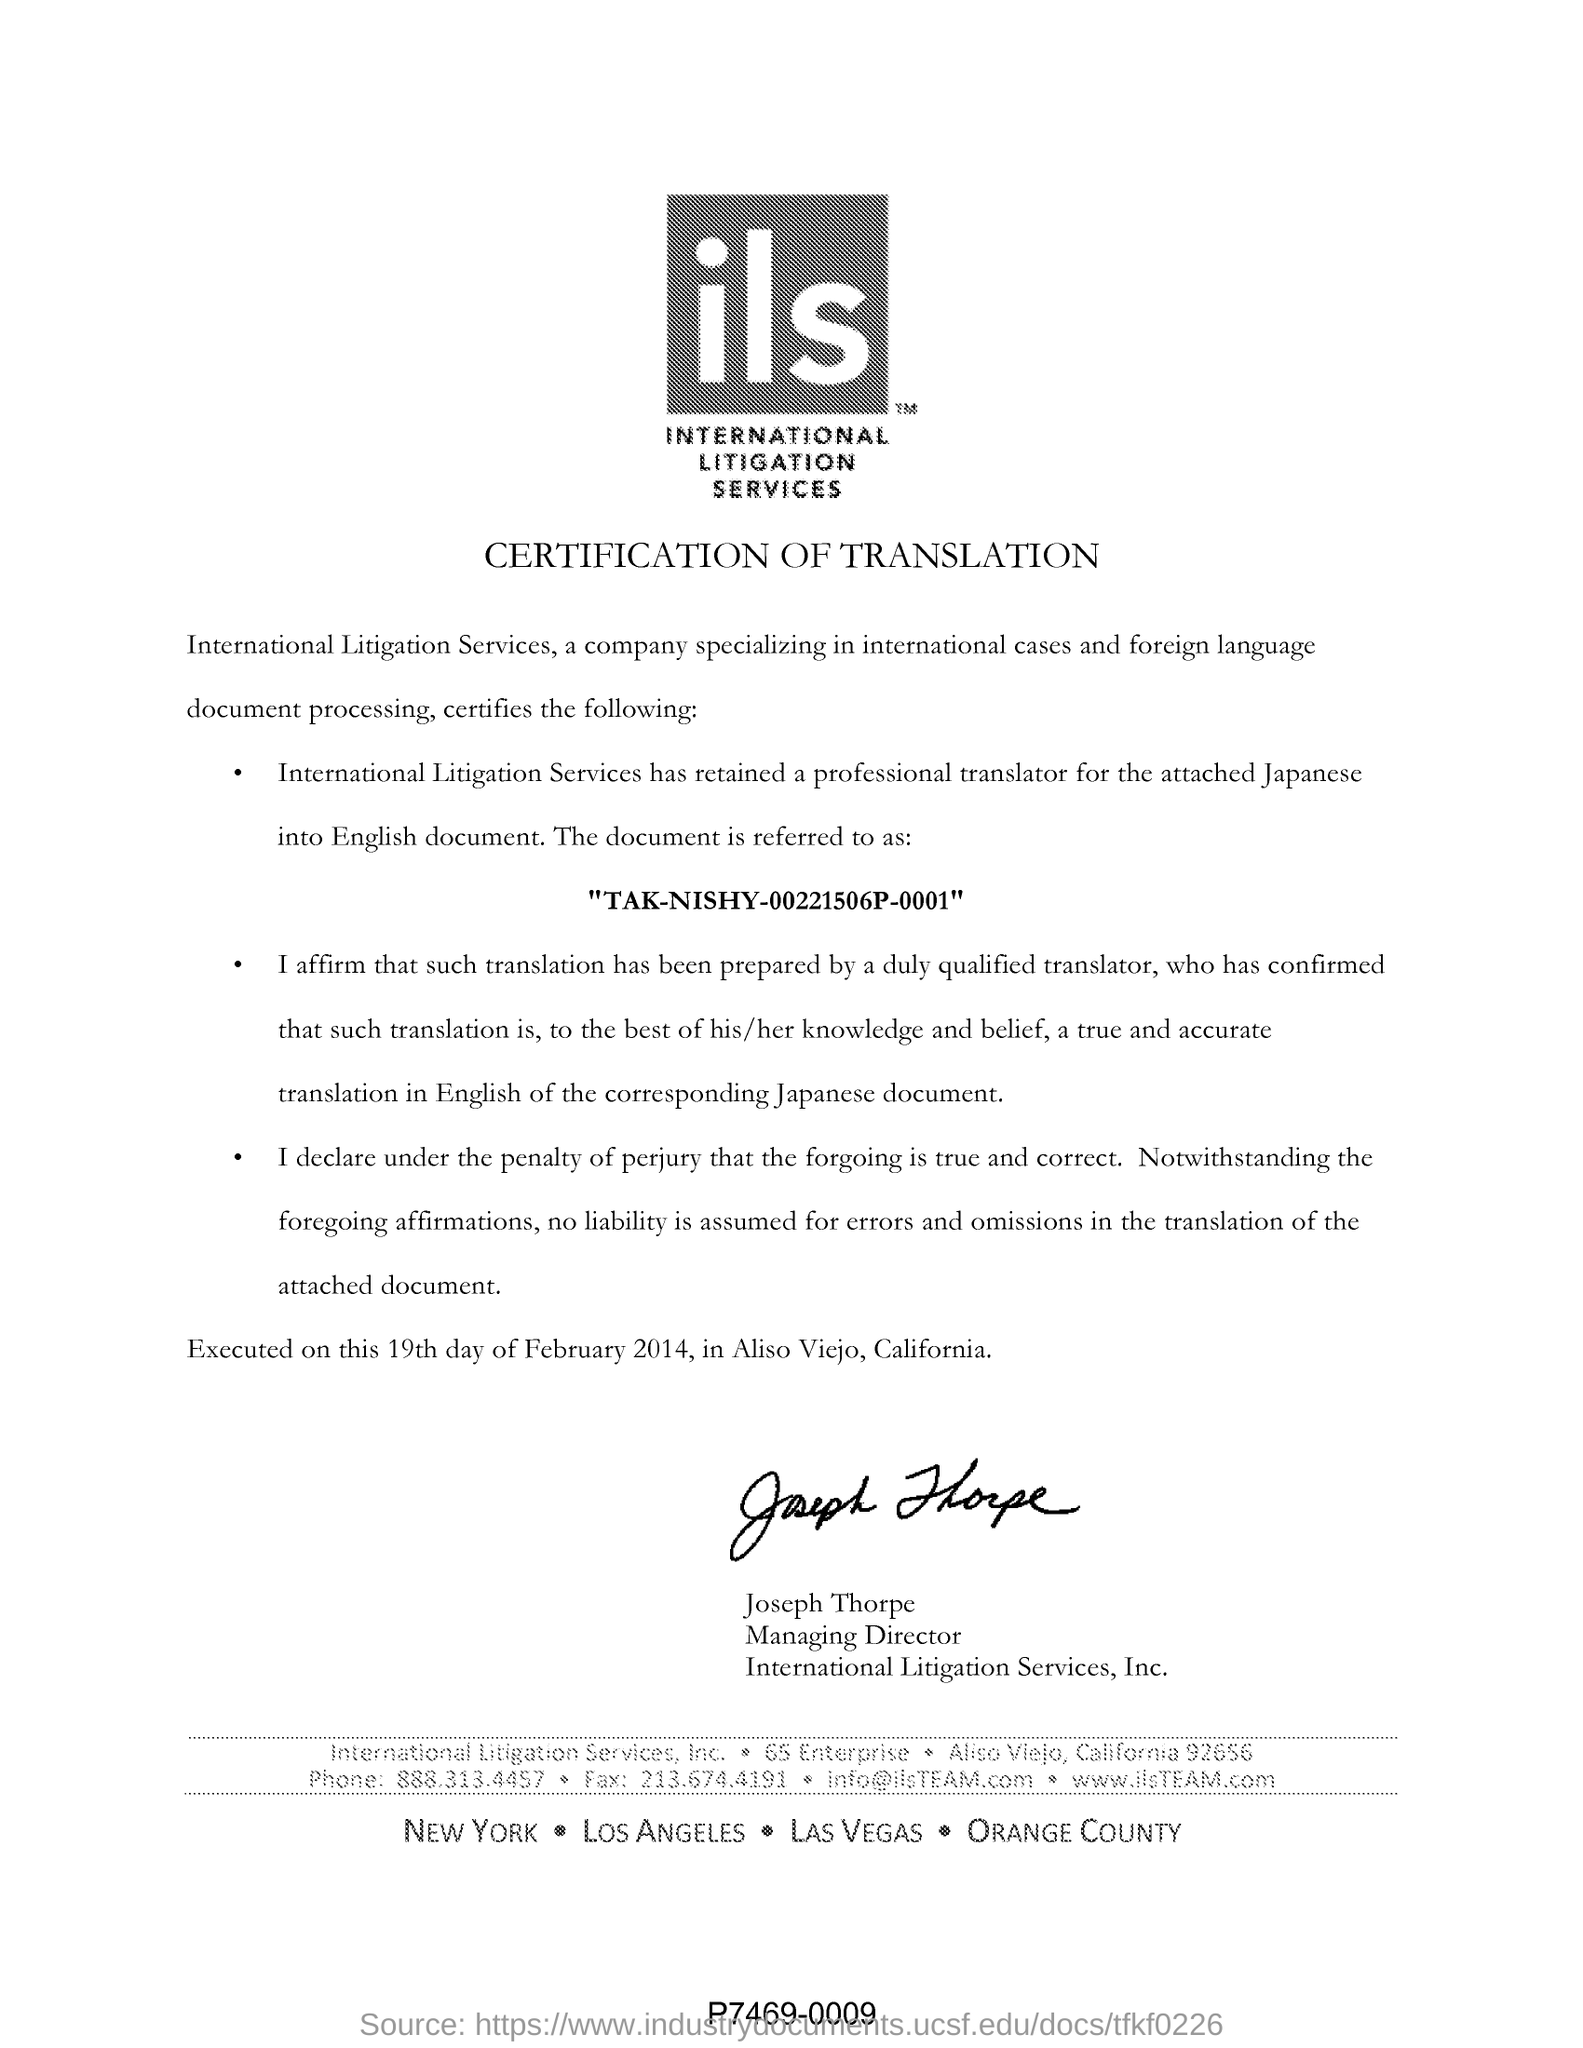List a handful of essential elements in this visual. The managing director of International Litigation Services, Inc. is Joseph Thorpe. International Litigation Services (ILS) is a fullform for a service that provides legal assistance and support to clients involved in international legal disputes. The individual in question retained the services of International Litigation Services, which specializes in providing professional translation services. 